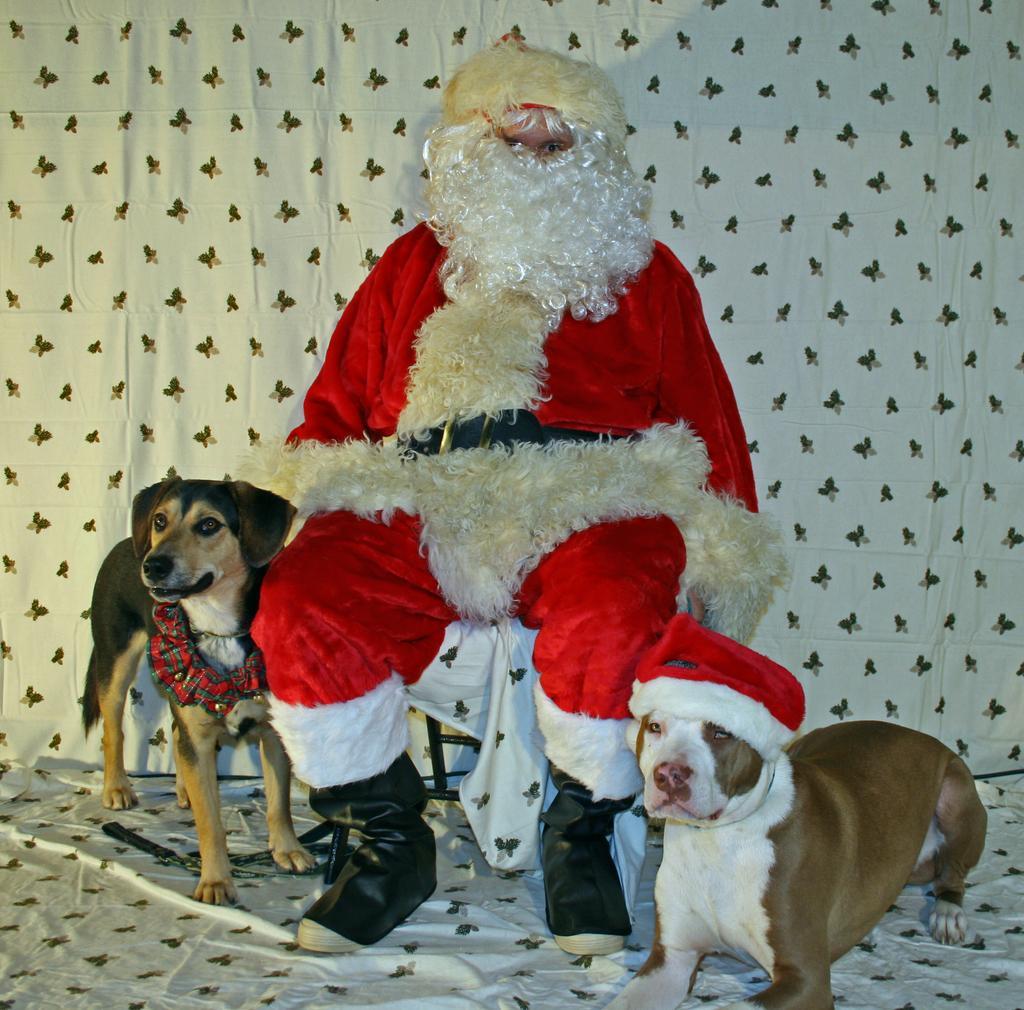In one or two sentences, can you explain what this image depicts? In this picture we can see a person in a fancy dress is sitting on a chair and on the left and right side of the person there are dogs. Behind the person there is a cloth. 